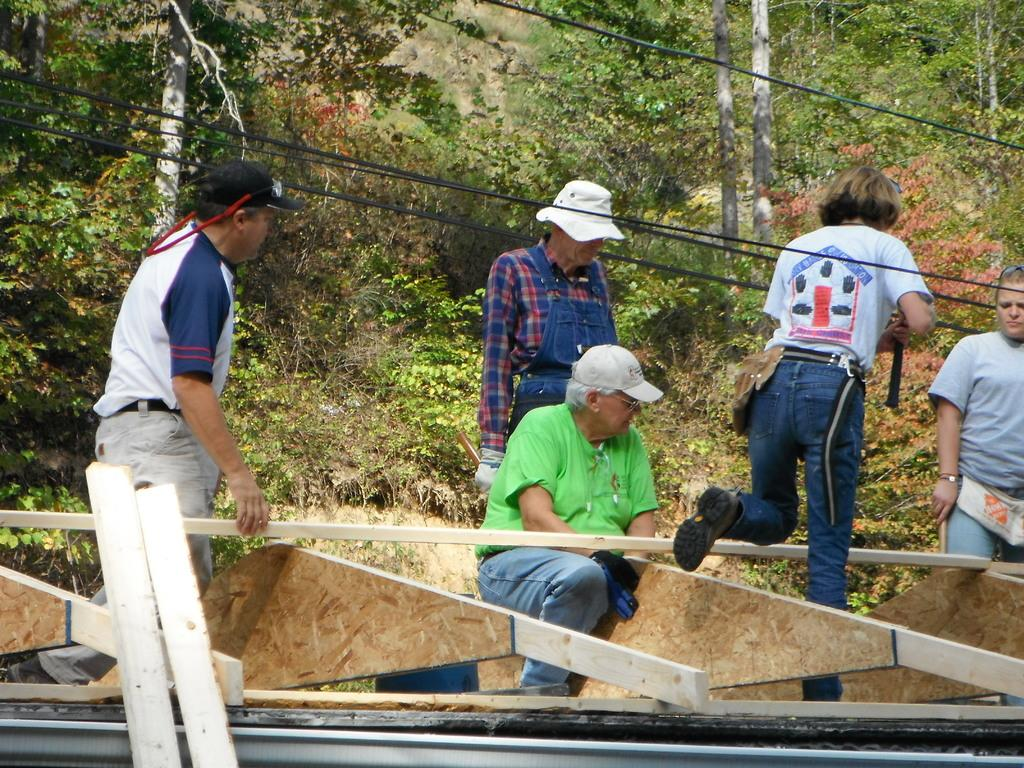What are the people in the image doing with the wooden fencing? The people in the image are holding wooden fencing. Is anyone sitting on the wooden fencing? Yes, one person is sitting on the wooden fencing. What can be seen in the background of the image? Trees, plants, and grass are visible in the background of the image. What type of agreement is being discussed by the people in the image? There is no indication in the image that the people are discussing any agreement. --- 